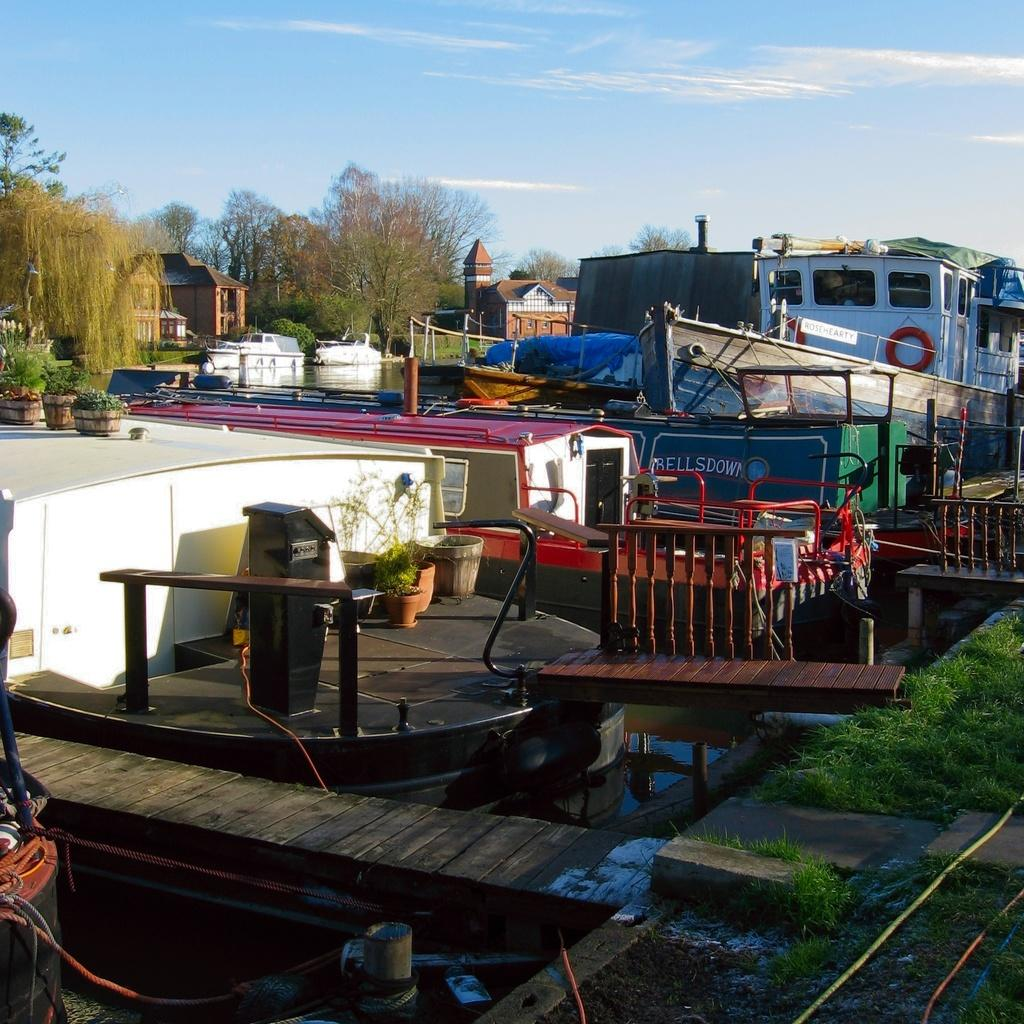What type of vehicles can be seen in the image? There are boats on the water in the image. What type of vegetation is present in the image? There are plants, trees, and grass in the image. What type of structures can be seen in the image? There are houses in the image. What type of construction can be seen in the image? There is a wooden pier in the image. What else can be seen in the image besides the boats, vegetation, structures, and pier? There are other items in the image. What is visible in the background of the image? The sky is visible in the background of the image. Can you tell me how many porters are carrying luggage on the wooden pier in the image? There is no mention of porters or luggage in the image; it features boats, vegetation, structures, and a pier. What type of crime is being committed in the image? There is no indication of any crime being committed in the image. 